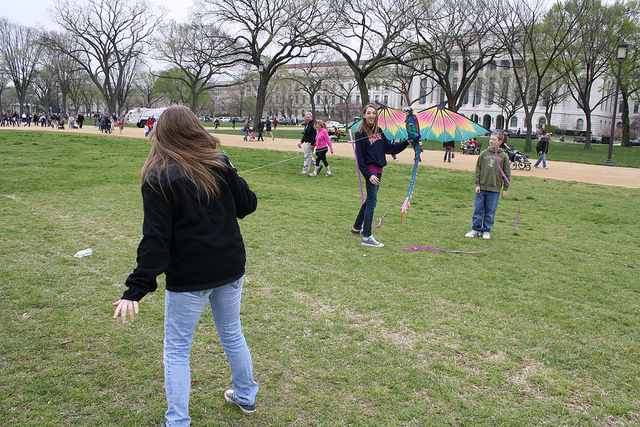What would you likely put in the thing on the ground that looks like garbage?
A. hamburger
B. dollar bills
C. toys
D. water The object on the ground, which resembles a piece of garbage, is actually a discarded caterpillar tunnel used in gardening to protect young plants. It's not intended for any of the listed items. However, if we consider typical scenarios, you wouldn't typically place a hamburger, dollar bills, or toys inside it. The most suitable option, only if this were not waste but a container to collect liquid, would be water (D). But again, it's important to note this item appears to be discarded and might not be suitable for use at all. 